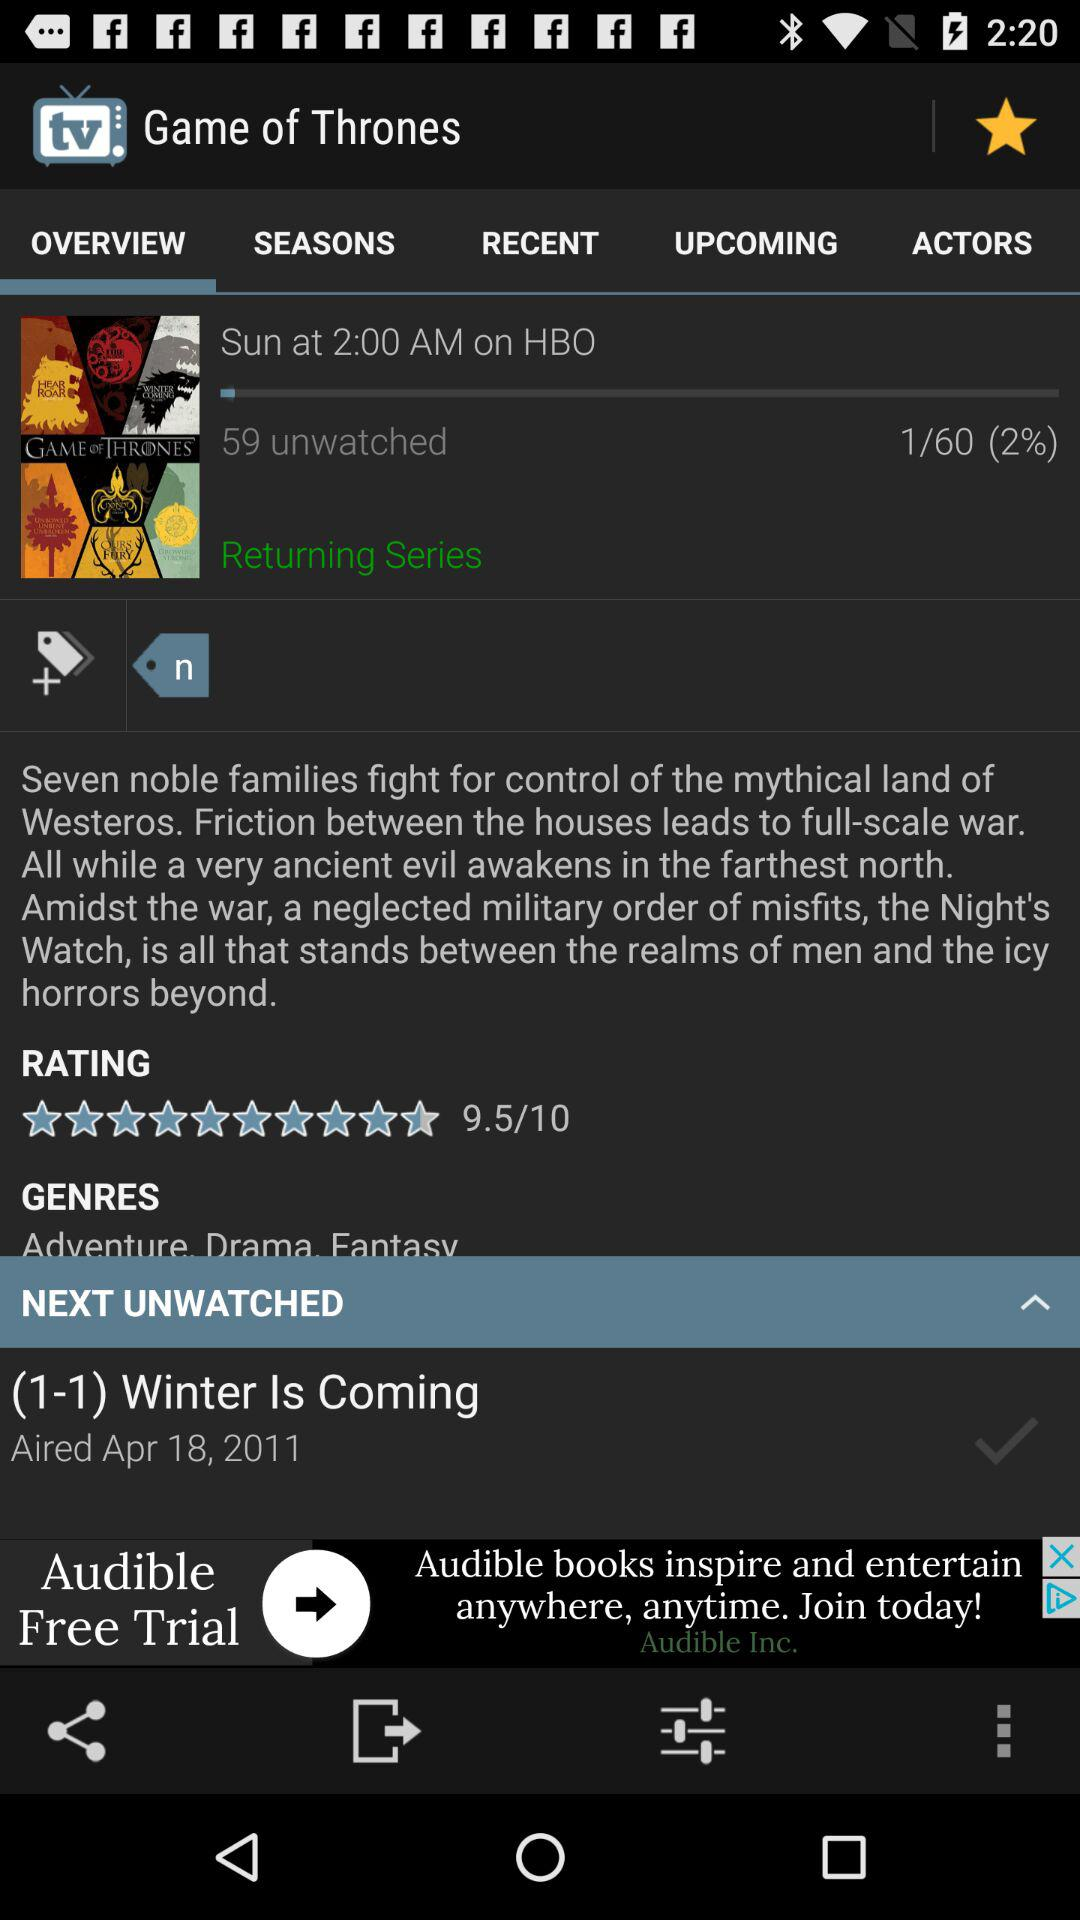What is the rating of the series "Game of Thrones"? The rating is 9.5. 